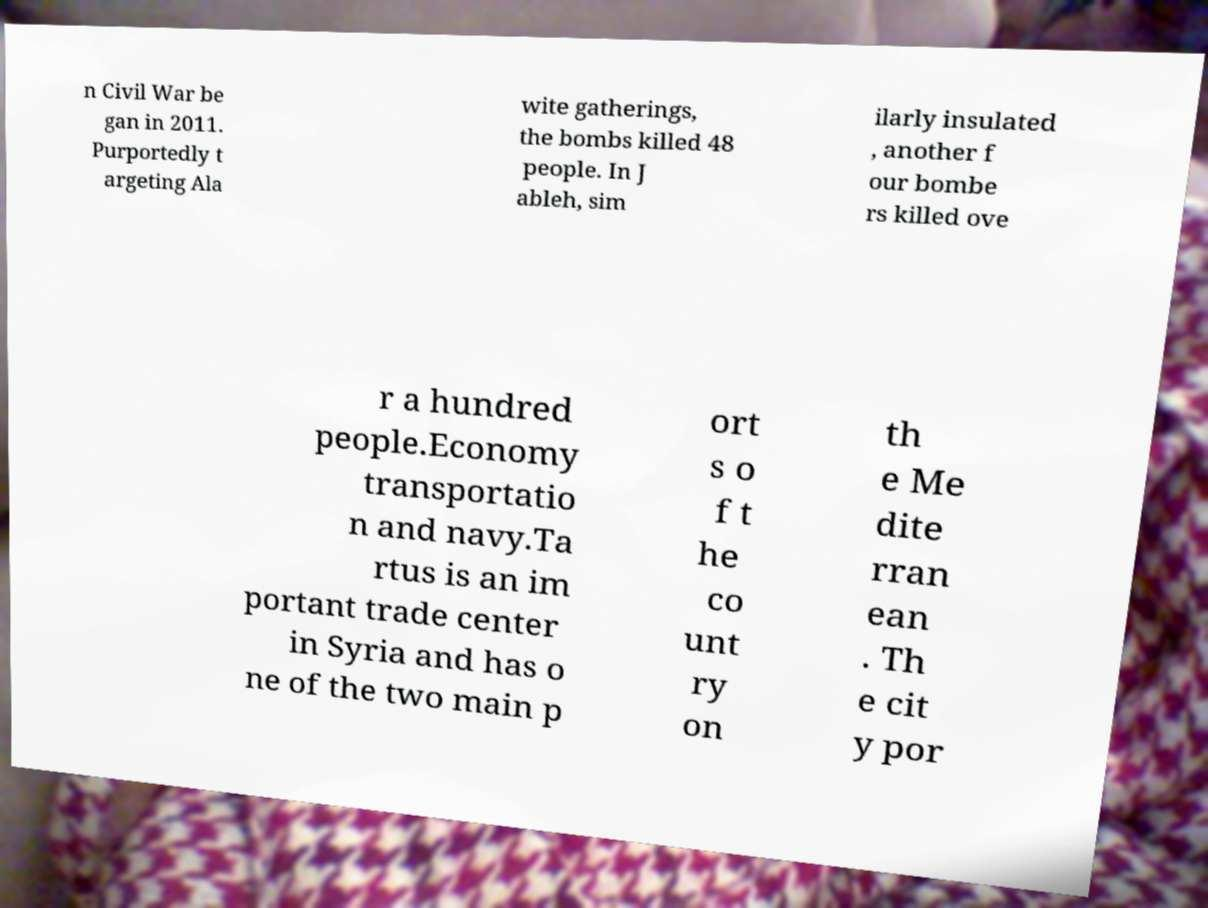Could you extract and type out the text from this image? n Civil War be gan in 2011. Purportedly t argeting Ala wite gatherings, the bombs killed 48 people. In J ableh, sim ilarly insulated , another f our bombe rs killed ove r a hundred people.Economy transportatio n and navy.Ta rtus is an im portant trade center in Syria and has o ne of the two main p ort s o f t he co unt ry on th e Me dite rran ean . Th e cit y por 